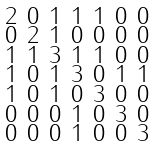<formula> <loc_0><loc_0><loc_500><loc_500>\begin{smallmatrix} 2 & 0 & 1 & 1 & 1 & 0 & 0 \\ 0 & 2 & 1 & 0 & 0 & 0 & 0 \\ 1 & 1 & 3 & 1 & 1 & 0 & 0 \\ 1 & 0 & 1 & 3 & 0 & 1 & 1 \\ 1 & 0 & 1 & 0 & 3 & 0 & 0 \\ 0 & 0 & 0 & 1 & 0 & 3 & 0 \\ 0 & 0 & 0 & 1 & 0 & 0 & 3 \end{smallmatrix}</formula> 